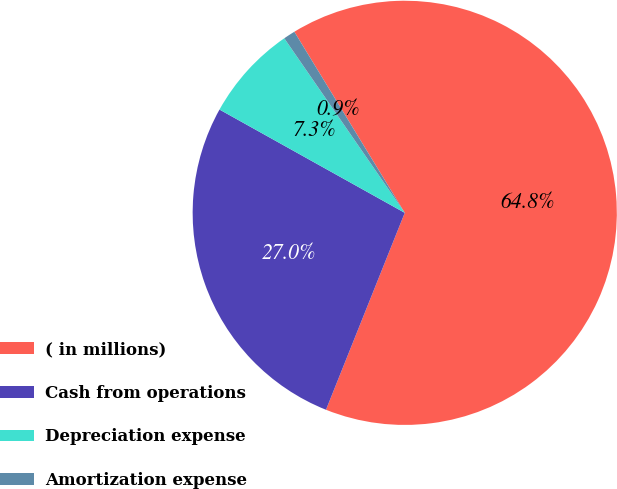<chart> <loc_0><loc_0><loc_500><loc_500><pie_chart><fcel>( in millions)<fcel>Cash from operations<fcel>Depreciation expense<fcel>Amortization expense<nl><fcel>64.77%<fcel>27.04%<fcel>7.29%<fcel>0.9%<nl></chart> 